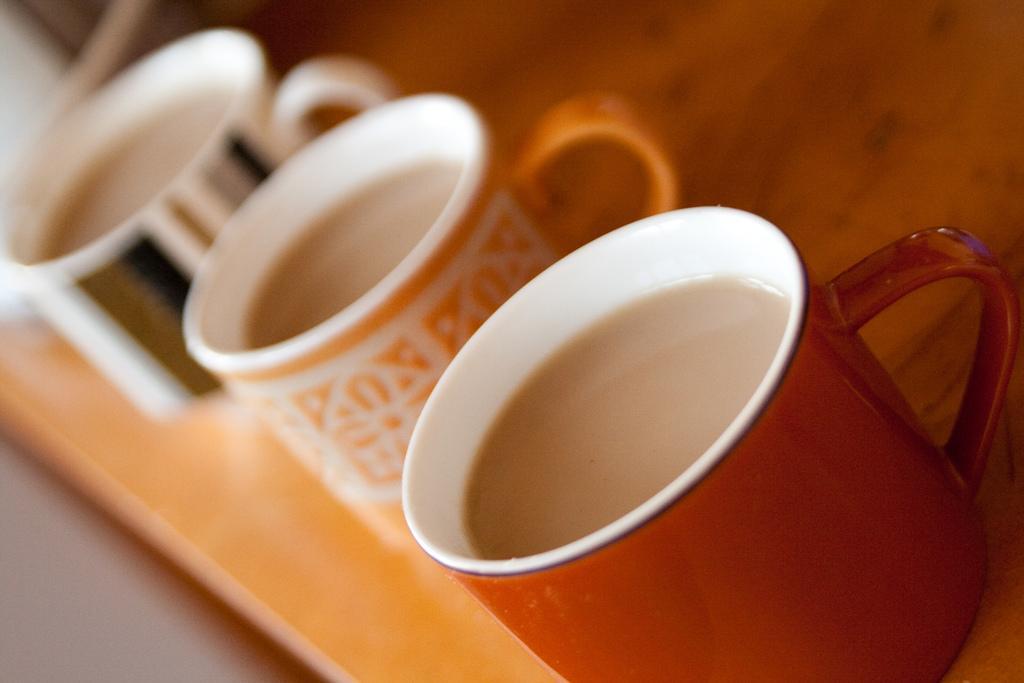Could you give a brief overview of what you see in this image? In this image in the foreground there is one tray, in that tree there are three cups. In the cups there is some drink. 